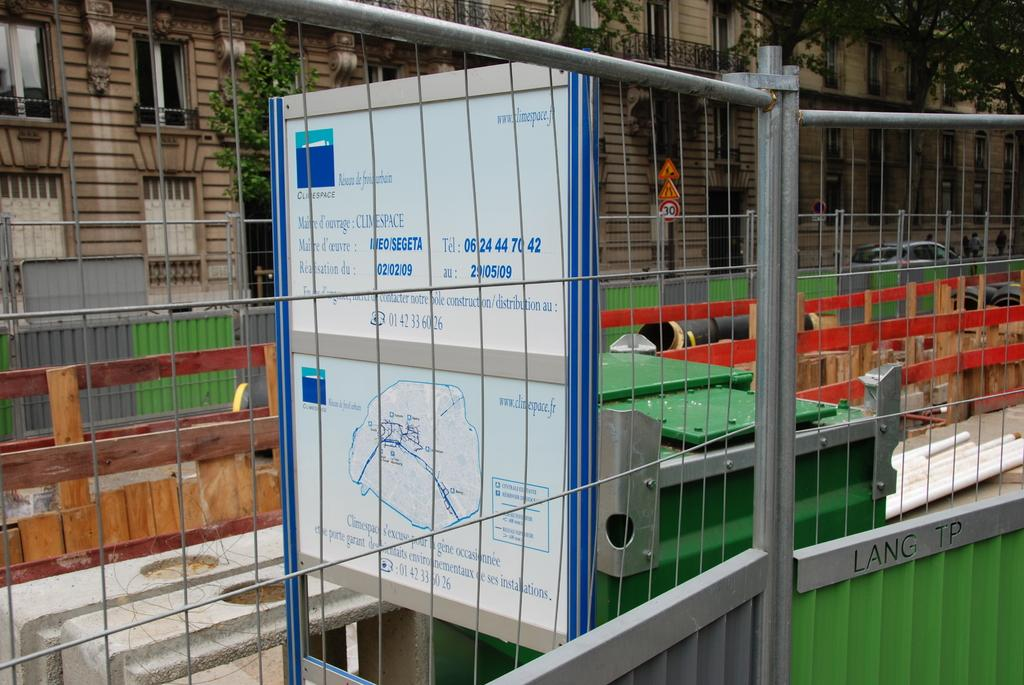What type of structures can be seen in the image? There are buildings in the image. What architectural features can be observed on the buildings? There are windows visible on the buildings. What natural elements are present in the image? There are trees in the image. What type of signage is present in the image? There are sign boards in the image. What mode of transportation can be seen in the image? There are motor vehicles in the image. What type of barrier is present in the image? There is an iron grill in the image. What type of informational displays are present in the image? There are information boards in the image. What type of waste disposal unit is present in the image? There is a bin in the image. How many frogs are sitting on the tray in the image? There is no tray or frogs present in the image. What type of store can be seen in the image? There is no store visible in the image. 